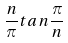Convert formula to latex. <formula><loc_0><loc_0><loc_500><loc_500>\frac { n } { \pi } t a n \frac { \pi } { n }</formula> 